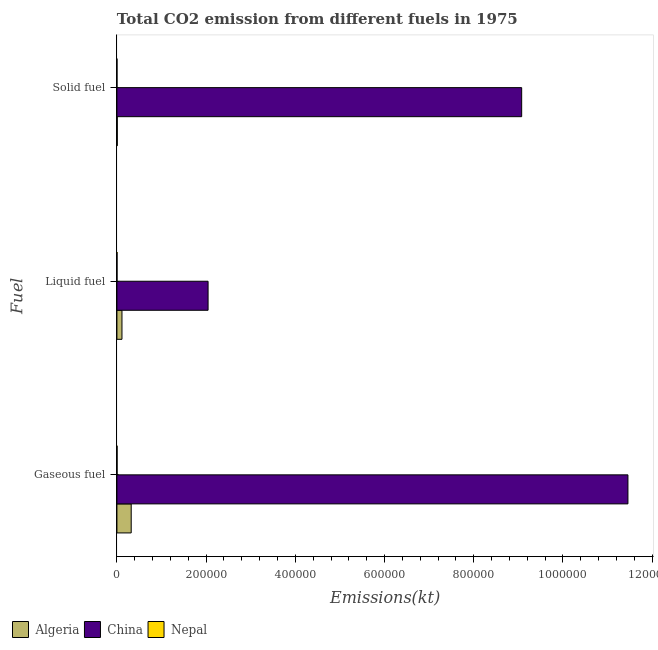How many bars are there on the 3rd tick from the top?
Offer a terse response. 3. How many bars are there on the 3rd tick from the bottom?
Give a very brief answer. 3. What is the label of the 1st group of bars from the top?
Provide a succinct answer. Solid fuel. What is the amount of co2 emissions from liquid fuel in Algeria?
Offer a terse response. 1.13e+04. Across all countries, what is the maximum amount of co2 emissions from liquid fuel?
Provide a short and direct response. 2.04e+05. Across all countries, what is the minimum amount of co2 emissions from gaseous fuel?
Your answer should be very brief. 352.03. In which country was the amount of co2 emissions from gaseous fuel minimum?
Give a very brief answer. Nepal. What is the total amount of co2 emissions from liquid fuel in the graph?
Ensure brevity in your answer.  2.16e+05. What is the difference between the amount of co2 emissions from gaseous fuel in Nepal and that in China?
Ensure brevity in your answer.  -1.15e+06. What is the difference between the amount of co2 emissions from gaseous fuel in Algeria and the amount of co2 emissions from liquid fuel in Nepal?
Your answer should be very brief. 3.18e+04. What is the average amount of co2 emissions from gaseous fuel per country?
Offer a very short reply. 3.93e+05. What is the difference between the amount of co2 emissions from liquid fuel and amount of co2 emissions from solid fuel in China?
Offer a very short reply. -7.03e+05. What is the ratio of the amount of co2 emissions from gaseous fuel in Nepal to that in Algeria?
Your answer should be very brief. 0.01. Is the difference between the amount of co2 emissions from gaseous fuel in China and Algeria greater than the difference between the amount of co2 emissions from solid fuel in China and Algeria?
Offer a very short reply. Yes. What is the difference between the highest and the second highest amount of co2 emissions from liquid fuel?
Provide a short and direct response. 1.93e+05. What is the difference between the highest and the lowest amount of co2 emissions from solid fuel?
Offer a terse response. 9.07e+05. Is the sum of the amount of co2 emissions from liquid fuel in Nepal and China greater than the maximum amount of co2 emissions from solid fuel across all countries?
Give a very brief answer. No. What does the 2nd bar from the top in Gaseous fuel represents?
Your answer should be very brief. China. How many bars are there?
Make the answer very short. 9. How many countries are there in the graph?
Make the answer very short. 3. What is the difference between two consecutive major ticks on the X-axis?
Give a very brief answer. 2.00e+05. Are the values on the major ticks of X-axis written in scientific E-notation?
Provide a succinct answer. No. Does the graph contain grids?
Make the answer very short. No. How are the legend labels stacked?
Your answer should be very brief. Horizontal. What is the title of the graph?
Provide a succinct answer. Total CO2 emission from different fuels in 1975. What is the label or title of the X-axis?
Make the answer very short. Emissions(kt). What is the label or title of the Y-axis?
Provide a succinct answer. Fuel. What is the Emissions(kt) of Algeria in Gaseous fuel?
Make the answer very short. 3.20e+04. What is the Emissions(kt) of China in Gaseous fuel?
Your answer should be compact. 1.15e+06. What is the Emissions(kt) in Nepal in Gaseous fuel?
Your response must be concise. 352.03. What is the Emissions(kt) in Algeria in Liquid fuel?
Give a very brief answer. 1.13e+04. What is the Emissions(kt) in China in Liquid fuel?
Your response must be concise. 2.04e+05. What is the Emissions(kt) in Nepal in Liquid fuel?
Your response must be concise. 223.69. What is the Emissions(kt) of Algeria in Solid fuel?
Offer a very short reply. 792.07. What is the Emissions(kt) of China in Solid fuel?
Ensure brevity in your answer.  9.07e+05. What is the Emissions(kt) in Nepal in Solid fuel?
Offer a very short reply. 124.68. Across all Fuel, what is the maximum Emissions(kt) in Algeria?
Provide a short and direct response. 3.20e+04. Across all Fuel, what is the maximum Emissions(kt) in China?
Provide a succinct answer. 1.15e+06. Across all Fuel, what is the maximum Emissions(kt) in Nepal?
Provide a succinct answer. 352.03. Across all Fuel, what is the minimum Emissions(kt) of Algeria?
Offer a terse response. 792.07. Across all Fuel, what is the minimum Emissions(kt) in China?
Offer a terse response. 2.04e+05. Across all Fuel, what is the minimum Emissions(kt) of Nepal?
Provide a succinct answer. 124.68. What is the total Emissions(kt) in Algeria in the graph?
Ensure brevity in your answer.  4.41e+04. What is the total Emissions(kt) in China in the graph?
Your response must be concise. 2.26e+06. What is the total Emissions(kt) in Nepal in the graph?
Make the answer very short. 700.4. What is the difference between the Emissions(kt) in Algeria in Gaseous fuel and that in Liquid fuel?
Offer a terse response. 2.07e+04. What is the difference between the Emissions(kt) of China in Gaseous fuel and that in Liquid fuel?
Offer a very short reply. 9.41e+05. What is the difference between the Emissions(kt) in Nepal in Gaseous fuel and that in Liquid fuel?
Give a very brief answer. 128.34. What is the difference between the Emissions(kt) in Algeria in Gaseous fuel and that in Solid fuel?
Provide a short and direct response. 3.12e+04. What is the difference between the Emissions(kt) of China in Gaseous fuel and that in Solid fuel?
Your response must be concise. 2.38e+05. What is the difference between the Emissions(kt) in Nepal in Gaseous fuel and that in Solid fuel?
Offer a very short reply. 227.35. What is the difference between the Emissions(kt) of Algeria in Liquid fuel and that in Solid fuel?
Your answer should be very brief. 1.05e+04. What is the difference between the Emissions(kt) in China in Liquid fuel and that in Solid fuel?
Make the answer very short. -7.03e+05. What is the difference between the Emissions(kt) in Nepal in Liquid fuel and that in Solid fuel?
Provide a succinct answer. 99.01. What is the difference between the Emissions(kt) of Algeria in Gaseous fuel and the Emissions(kt) of China in Liquid fuel?
Provide a succinct answer. -1.72e+05. What is the difference between the Emissions(kt) in Algeria in Gaseous fuel and the Emissions(kt) in Nepal in Liquid fuel?
Offer a very short reply. 3.18e+04. What is the difference between the Emissions(kt) in China in Gaseous fuel and the Emissions(kt) in Nepal in Liquid fuel?
Provide a short and direct response. 1.15e+06. What is the difference between the Emissions(kt) of Algeria in Gaseous fuel and the Emissions(kt) of China in Solid fuel?
Offer a very short reply. -8.75e+05. What is the difference between the Emissions(kt) of Algeria in Gaseous fuel and the Emissions(kt) of Nepal in Solid fuel?
Offer a terse response. 3.19e+04. What is the difference between the Emissions(kt) of China in Gaseous fuel and the Emissions(kt) of Nepal in Solid fuel?
Ensure brevity in your answer.  1.15e+06. What is the difference between the Emissions(kt) in Algeria in Liquid fuel and the Emissions(kt) in China in Solid fuel?
Offer a very short reply. -8.96e+05. What is the difference between the Emissions(kt) of Algeria in Liquid fuel and the Emissions(kt) of Nepal in Solid fuel?
Make the answer very short. 1.12e+04. What is the difference between the Emissions(kt) in China in Liquid fuel and the Emissions(kt) in Nepal in Solid fuel?
Your answer should be very brief. 2.04e+05. What is the average Emissions(kt) in Algeria per Fuel?
Provide a short and direct response. 1.47e+04. What is the average Emissions(kt) in China per Fuel?
Your answer should be very brief. 7.52e+05. What is the average Emissions(kt) in Nepal per Fuel?
Provide a succinct answer. 233.47. What is the difference between the Emissions(kt) of Algeria and Emissions(kt) of China in Gaseous fuel?
Your response must be concise. -1.11e+06. What is the difference between the Emissions(kt) in Algeria and Emissions(kt) in Nepal in Gaseous fuel?
Offer a very short reply. 3.17e+04. What is the difference between the Emissions(kt) of China and Emissions(kt) of Nepal in Gaseous fuel?
Your answer should be very brief. 1.15e+06. What is the difference between the Emissions(kt) in Algeria and Emissions(kt) in China in Liquid fuel?
Your answer should be very brief. -1.93e+05. What is the difference between the Emissions(kt) in Algeria and Emissions(kt) in Nepal in Liquid fuel?
Offer a terse response. 1.11e+04. What is the difference between the Emissions(kt) of China and Emissions(kt) of Nepal in Liquid fuel?
Your answer should be compact. 2.04e+05. What is the difference between the Emissions(kt) in Algeria and Emissions(kt) in China in Solid fuel?
Keep it short and to the point. -9.07e+05. What is the difference between the Emissions(kt) of Algeria and Emissions(kt) of Nepal in Solid fuel?
Your response must be concise. 667.39. What is the difference between the Emissions(kt) of China and Emissions(kt) of Nepal in Solid fuel?
Provide a succinct answer. 9.07e+05. What is the ratio of the Emissions(kt) of Algeria in Gaseous fuel to that in Liquid fuel?
Make the answer very short. 2.83. What is the ratio of the Emissions(kt) of China in Gaseous fuel to that in Liquid fuel?
Give a very brief answer. 5.61. What is the ratio of the Emissions(kt) of Nepal in Gaseous fuel to that in Liquid fuel?
Offer a terse response. 1.57. What is the ratio of the Emissions(kt) in Algeria in Gaseous fuel to that in Solid fuel?
Your response must be concise. 40.44. What is the ratio of the Emissions(kt) in China in Gaseous fuel to that in Solid fuel?
Offer a terse response. 1.26. What is the ratio of the Emissions(kt) in Nepal in Gaseous fuel to that in Solid fuel?
Provide a succinct answer. 2.82. What is the ratio of the Emissions(kt) in Algeria in Liquid fuel to that in Solid fuel?
Give a very brief answer. 14.27. What is the ratio of the Emissions(kt) in China in Liquid fuel to that in Solid fuel?
Make the answer very short. 0.23. What is the ratio of the Emissions(kt) in Nepal in Liquid fuel to that in Solid fuel?
Your response must be concise. 1.79. What is the difference between the highest and the second highest Emissions(kt) of Algeria?
Make the answer very short. 2.07e+04. What is the difference between the highest and the second highest Emissions(kt) in China?
Offer a terse response. 2.38e+05. What is the difference between the highest and the second highest Emissions(kt) in Nepal?
Offer a very short reply. 128.34. What is the difference between the highest and the lowest Emissions(kt) of Algeria?
Give a very brief answer. 3.12e+04. What is the difference between the highest and the lowest Emissions(kt) of China?
Offer a terse response. 9.41e+05. What is the difference between the highest and the lowest Emissions(kt) of Nepal?
Provide a short and direct response. 227.35. 